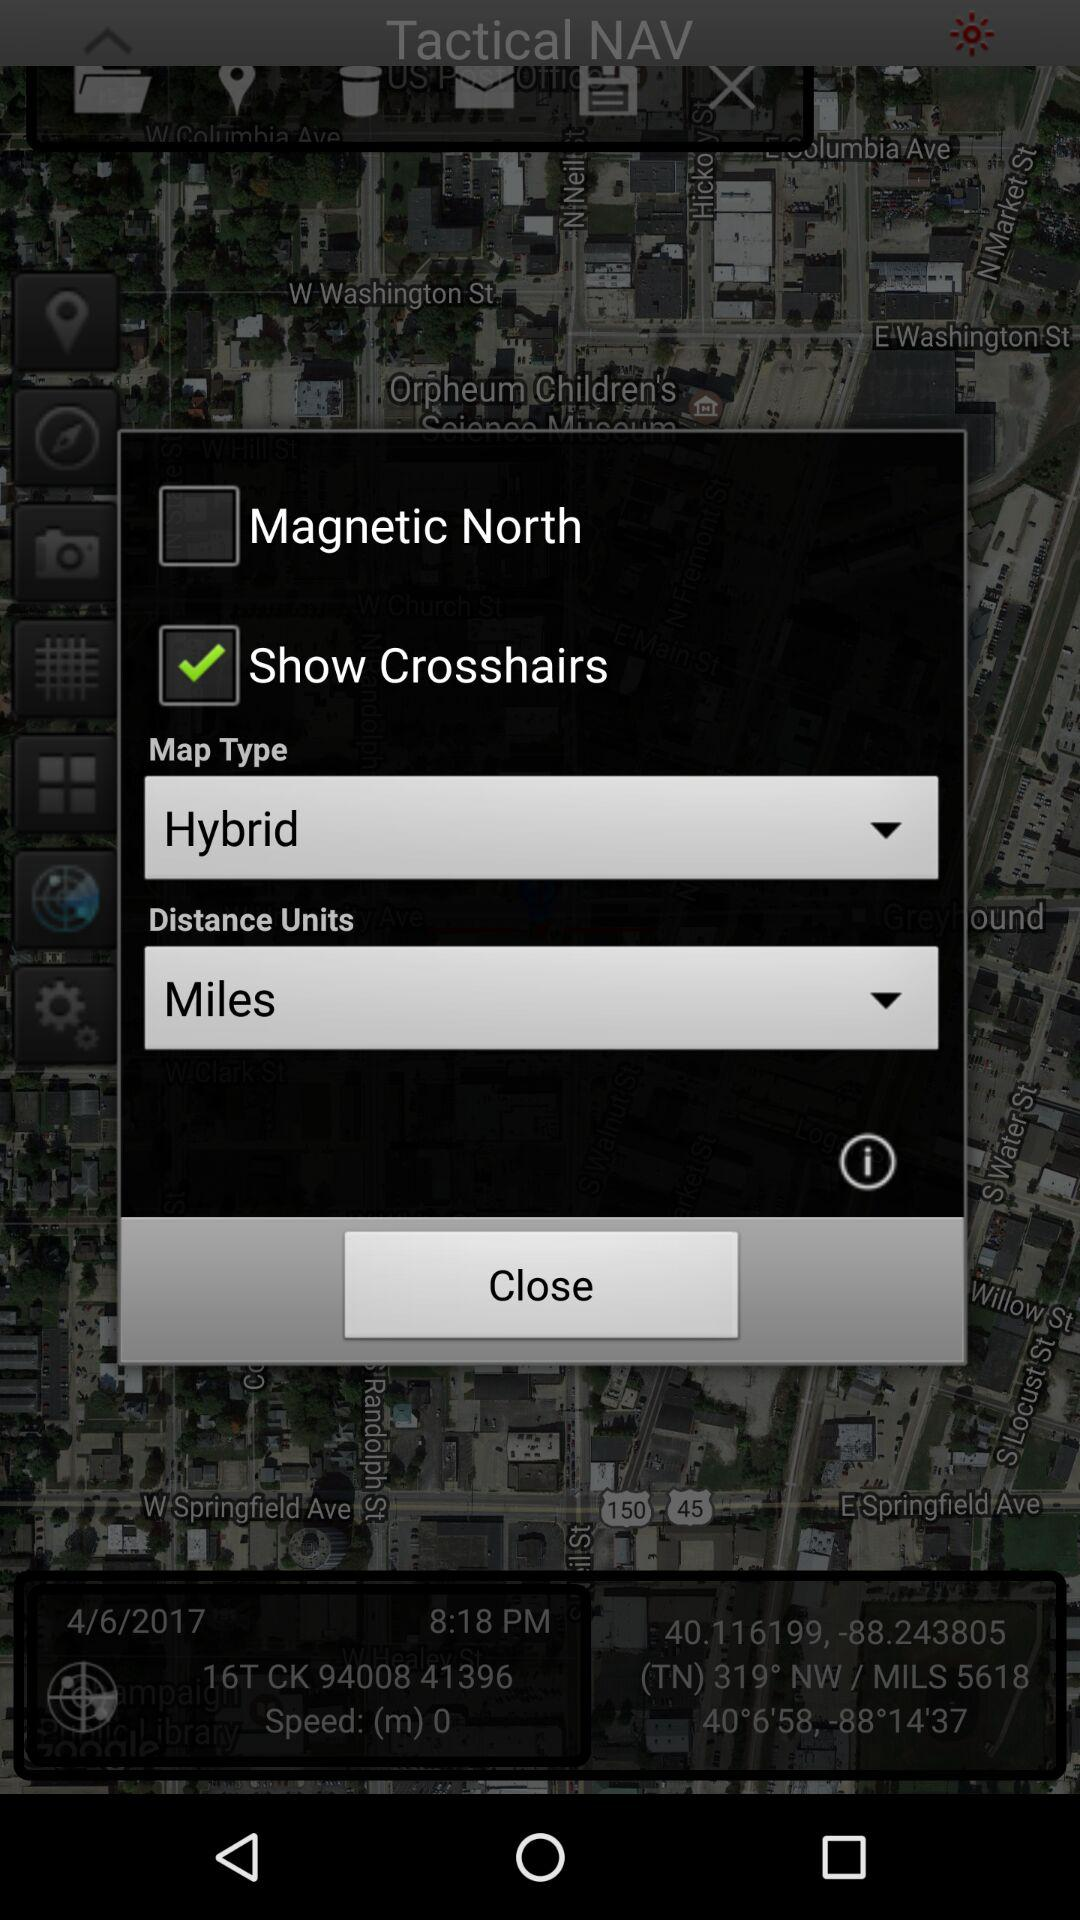What is the map type? The map type is "Hybrid". 